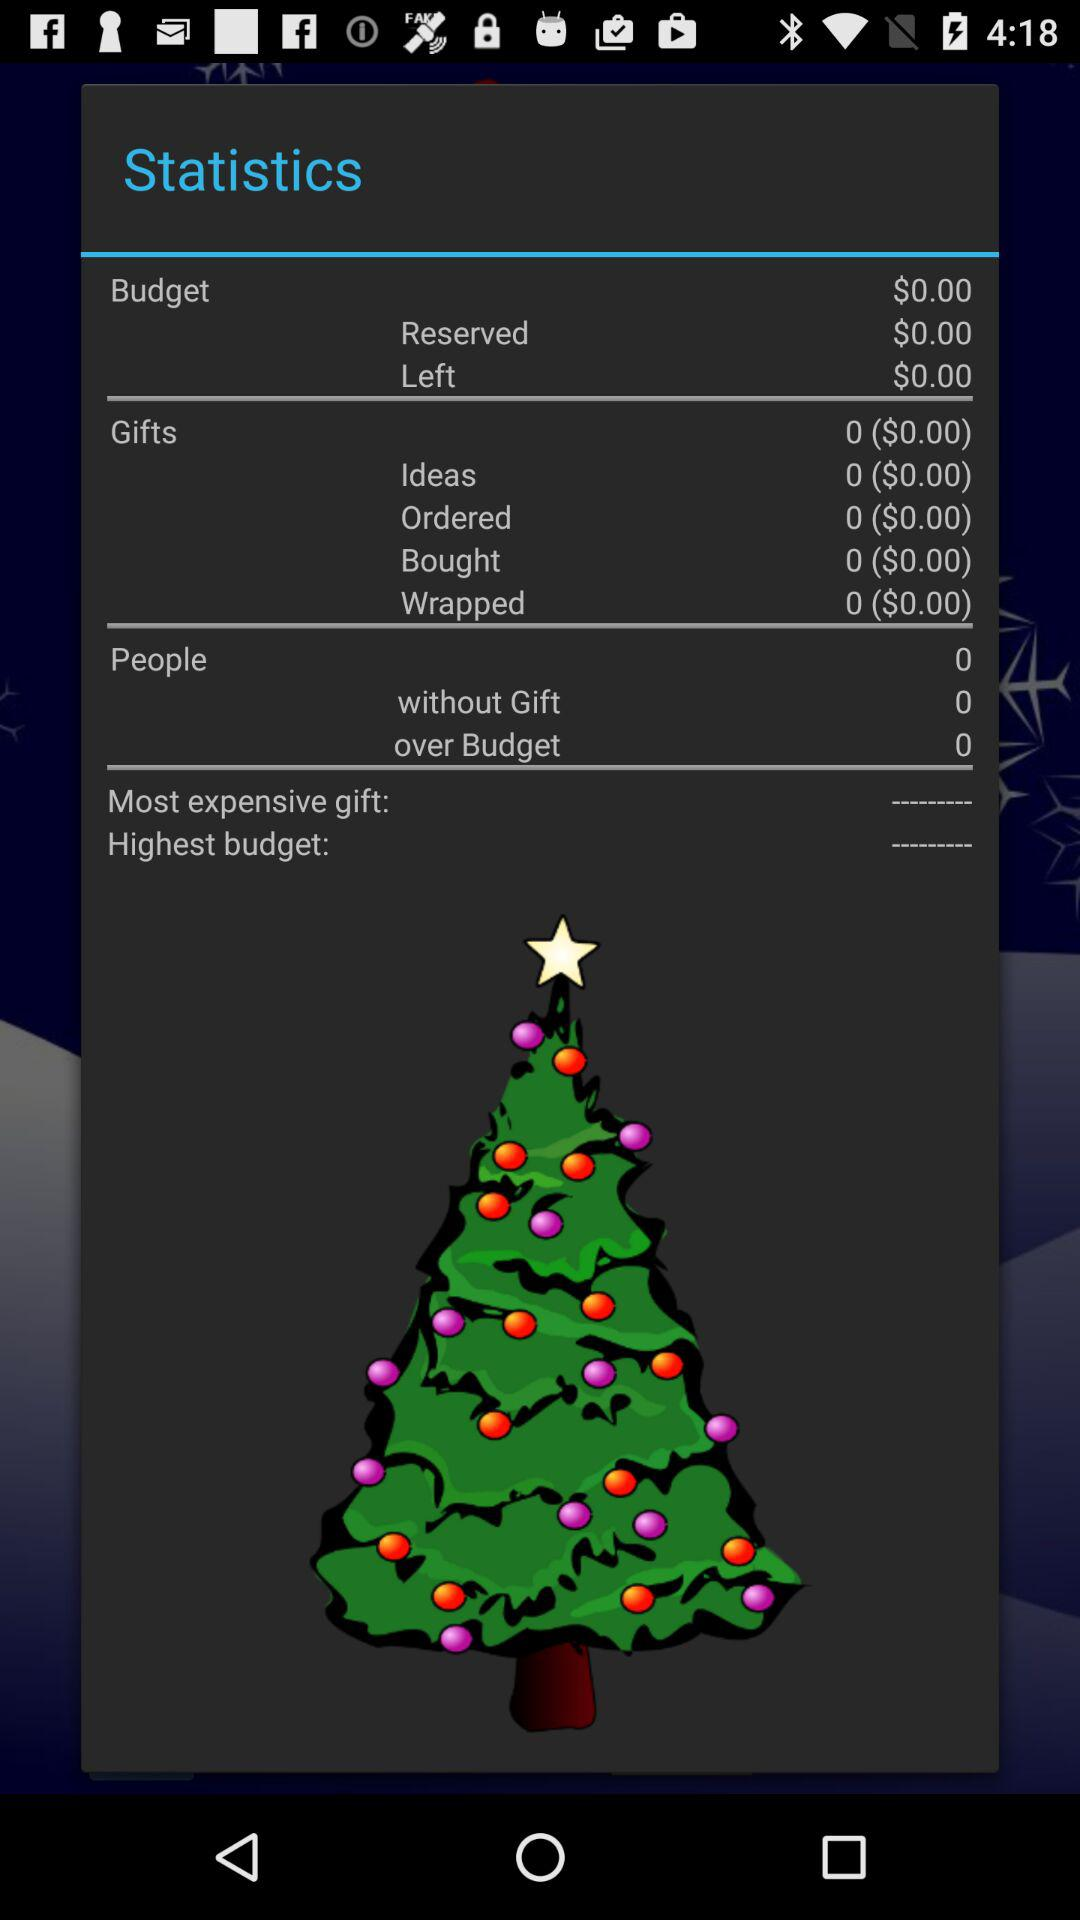What is the currency type for wrapped gifts? The currency is $. 